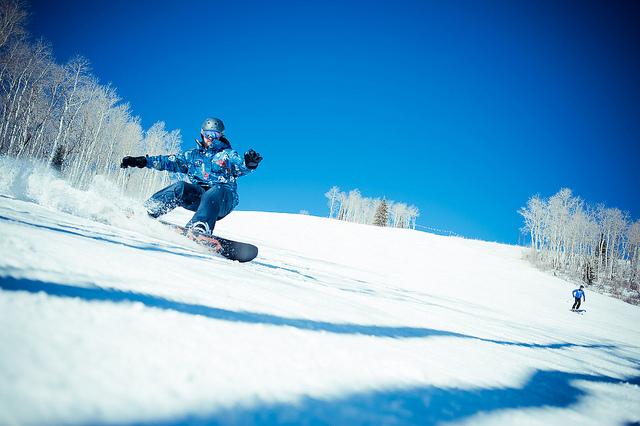Is the snowboard flat on its bottom edge?
Be succinct. No. Are there any clouds in the sky?
Answer briefly. No. What color is the girls snowboard?
Short answer required. Blue. Are the trees bare?
Keep it brief. Yes. 